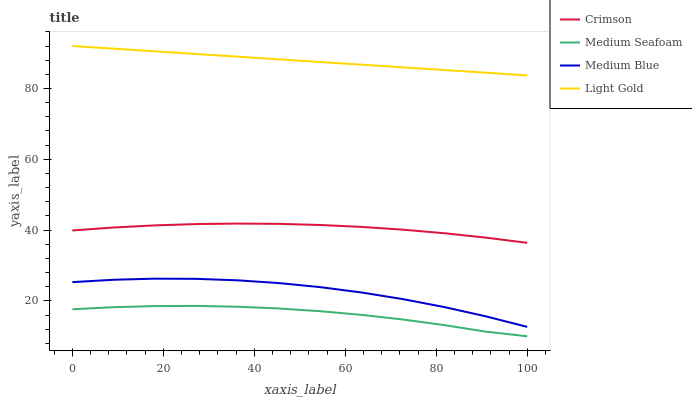Does Medium Seafoam have the minimum area under the curve?
Answer yes or no. Yes. Does Light Gold have the maximum area under the curve?
Answer yes or no. Yes. Does Medium Blue have the minimum area under the curve?
Answer yes or no. No. Does Medium Blue have the maximum area under the curve?
Answer yes or no. No. Is Light Gold the smoothest?
Answer yes or no. Yes. Is Medium Blue the roughest?
Answer yes or no. Yes. Is Medium Blue the smoothest?
Answer yes or no. No. Is Light Gold the roughest?
Answer yes or no. No. Does Medium Seafoam have the lowest value?
Answer yes or no. Yes. Does Medium Blue have the lowest value?
Answer yes or no. No. Does Light Gold have the highest value?
Answer yes or no. Yes. Does Medium Blue have the highest value?
Answer yes or no. No. Is Medium Seafoam less than Crimson?
Answer yes or no. Yes. Is Light Gold greater than Crimson?
Answer yes or no. Yes. Does Medium Seafoam intersect Crimson?
Answer yes or no. No. 